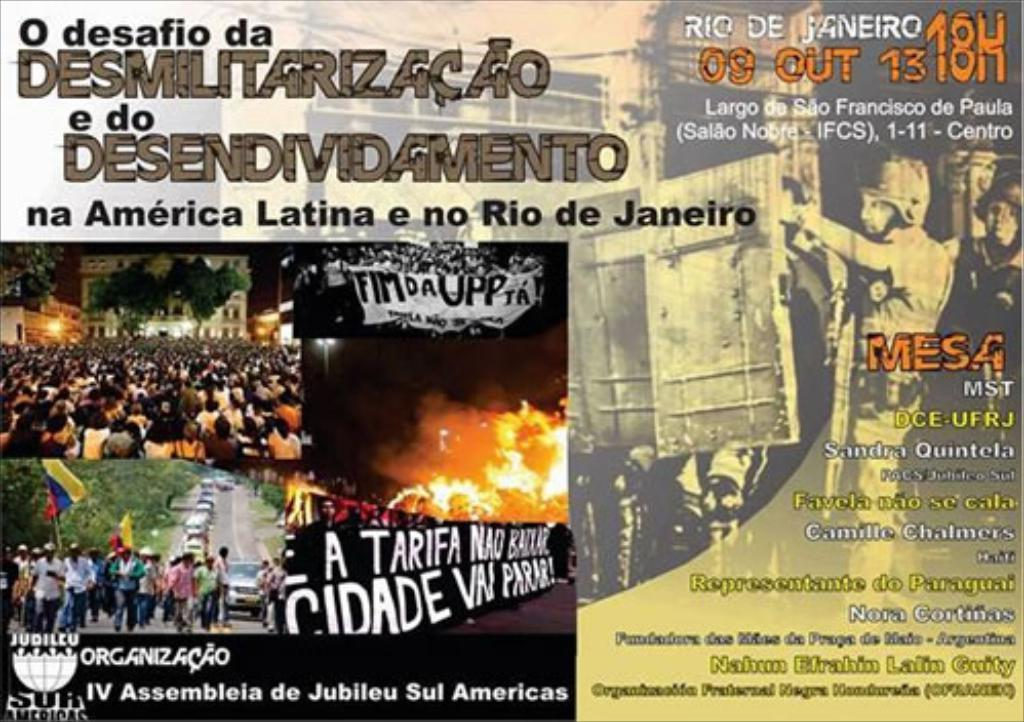<image>
Write a terse but informative summary of the picture. A poster that reads O desafio da Sesmilitarizacao e do Desendividamento in portugese on the top left hand side of the poster. 